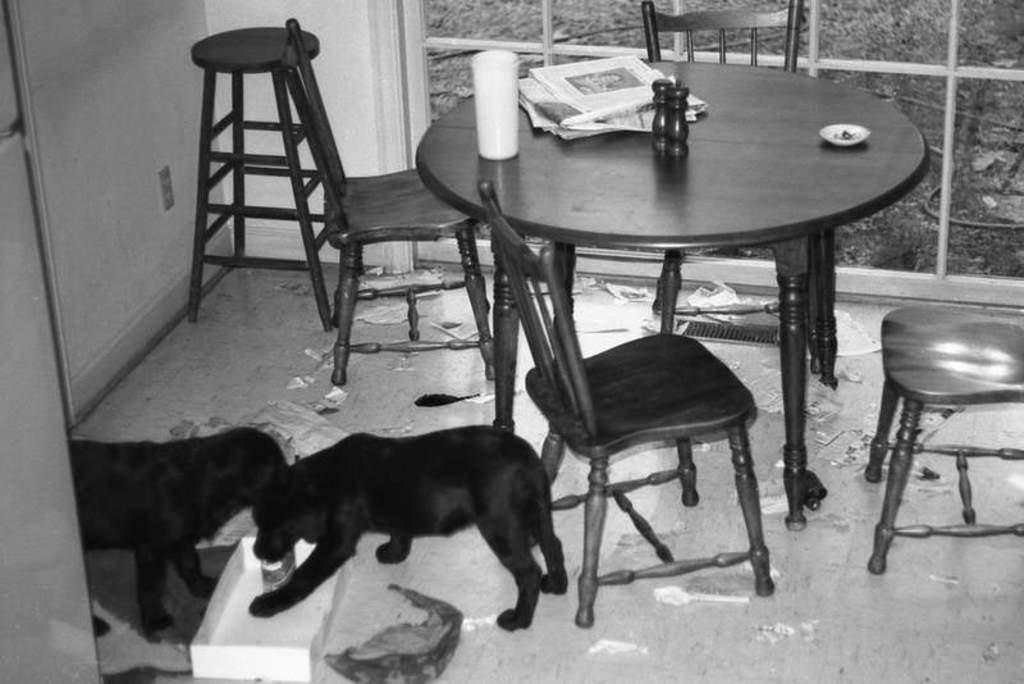Describe this image in one or two sentences. In this picture there is a table and chairs around it, at the right side of the image, there are dogs at the left side of the image and there are eating something from the box, it seems to be a dirty area of a room and there is news paper on the table. 